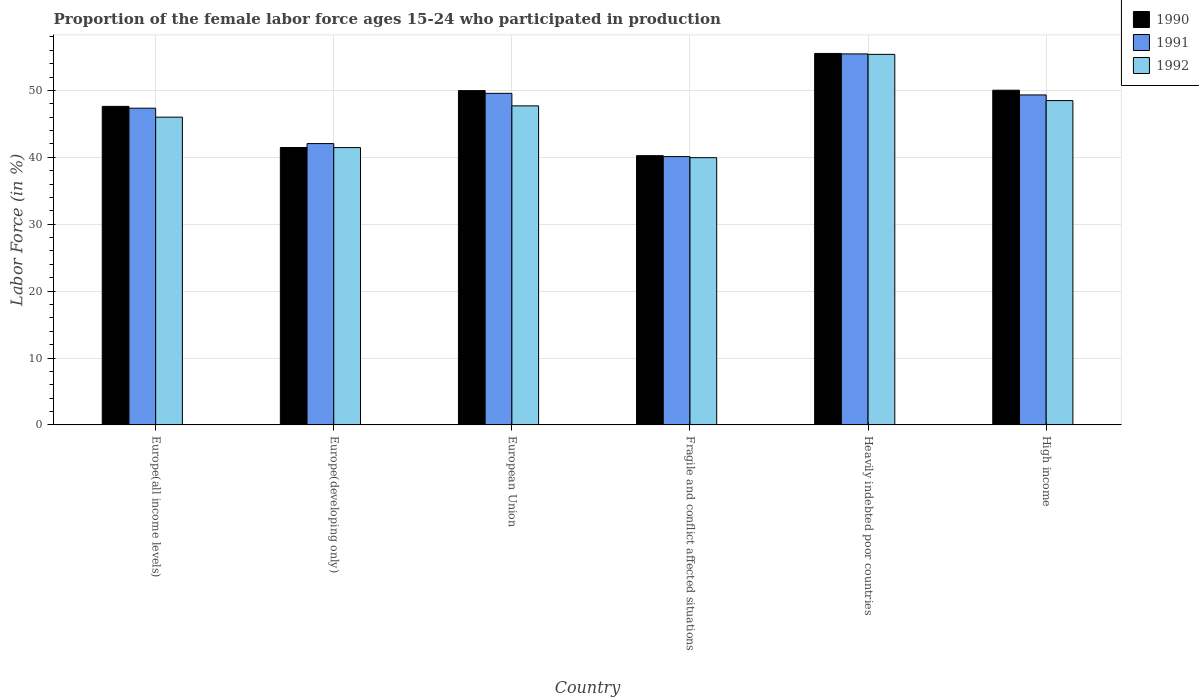How many different coloured bars are there?
Your answer should be compact. 3. How many bars are there on the 5th tick from the left?
Your answer should be compact. 3. What is the label of the 5th group of bars from the left?
Offer a terse response. Heavily indebted poor countries. What is the proportion of the female labor force who participated in production in 1991 in Fragile and conflict affected situations?
Keep it short and to the point. 40.11. Across all countries, what is the maximum proportion of the female labor force who participated in production in 1991?
Provide a short and direct response. 55.46. Across all countries, what is the minimum proportion of the female labor force who participated in production in 1990?
Offer a terse response. 40.25. In which country was the proportion of the female labor force who participated in production in 1992 maximum?
Make the answer very short. Heavily indebted poor countries. In which country was the proportion of the female labor force who participated in production in 1991 minimum?
Keep it short and to the point. Fragile and conflict affected situations. What is the total proportion of the female labor force who participated in production in 1990 in the graph?
Give a very brief answer. 284.87. What is the difference between the proportion of the female labor force who participated in production in 1992 in Europe(all income levels) and that in Heavily indebted poor countries?
Your response must be concise. -9.39. What is the difference between the proportion of the female labor force who participated in production in 1990 in Fragile and conflict affected situations and the proportion of the female labor force who participated in production in 1991 in Heavily indebted poor countries?
Offer a very short reply. -15.21. What is the average proportion of the female labor force who participated in production in 1992 per country?
Offer a very short reply. 46.5. What is the difference between the proportion of the female labor force who participated in production of/in 1990 and proportion of the female labor force who participated in production of/in 1992 in High income?
Offer a very short reply. 1.55. In how many countries, is the proportion of the female labor force who participated in production in 1992 greater than 24 %?
Make the answer very short. 6. What is the ratio of the proportion of the female labor force who participated in production in 1990 in Heavily indebted poor countries to that in High income?
Make the answer very short. 1.11. Is the proportion of the female labor force who participated in production in 1991 in Europe(all income levels) less than that in Heavily indebted poor countries?
Your response must be concise. Yes. Is the difference between the proportion of the female labor force who participated in production in 1990 in Europe(developing only) and European Union greater than the difference between the proportion of the female labor force who participated in production in 1992 in Europe(developing only) and European Union?
Ensure brevity in your answer.  No. What is the difference between the highest and the second highest proportion of the female labor force who participated in production in 1992?
Make the answer very short. 0.79. What is the difference between the highest and the lowest proportion of the female labor force who participated in production in 1992?
Your response must be concise. 15.44. Is the sum of the proportion of the female labor force who participated in production in 1992 in Fragile and conflict affected situations and Heavily indebted poor countries greater than the maximum proportion of the female labor force who participated in production in 1990 across all countries?
Ensure brevity in your answer.  Yes. Is it the case that in every country, the sum of the proportion of the female labor force who participated in production in 1990 and proportion of the female labor force who participated in production in 1992 is greater than the proportion of the female labor force who participated in production in 1991?
Offer a very short reply. Yes. How many bars are there?
Your response must be concise. 18. How many countries are there in the graph?
Make the answer very short. 6. What is the difference between two consecutive major ticks on the Y-axis?
Give a very brief answer. 10. Does the graph contain any zero values?
Ensure brevity in your answer.  No. How many legend labels are there?
Provide a short and direct response. 3. How are the legend labels stacked?
Your response must be concise. Vertical. What is the title of the graph?
Your response must be concise. Proportion of the female labor force ages 15-24 who participated in production. What is the Labor Force (in %) of 1990 in Europe(all income levels)?
Provide a short and direct response. 47.62. What is the Labor Force (in %) in 1991 in Europe(all income levels)?
Offer a terse response. 47.34. What is the Labor Force (in %) in 1992 in Europe(all income levels)?
Your response must be concise. 46. What is the Labor Force (in %) of 1990 in Europe(developing only)?
Ensure brevity in your answer.  41.47. What is the Labor Force (in %) in 1991 in Europe(developing only)?
Offer a terse response. 42.05. What is the Labor Force (in %) in 1992 in Europe(developing only)?
Your response must be concise. 41.46. What is the Labor Force (in %) in 1990 in European Union?
Offer a terse response. 49.97. What is the Labor Force (in %) of 1991 in European Union?
Offer a very short reply. 49.57. What is the Labor Force (in %) in 1992 in European Union?
Offer a terse response. 47.7. What is the Labor Force (in %) in 1990 in Fragile and conflict affected situations?
Provide a short and direct response. 40.25. What is the Labor Force (in %) of 1991 in Fragile and conflict affected situations?
Provide a short and direct response. 40.11. What is the Labor Force (in %) in 1992 in Fragile and conflict affected situations?
Keep it short and to the point. 39.95. What is the Labor Force (in %) of 1990 in Heavily indebted poor countries?
Provide a succinct answer. 55.53. What is the Labor Force (in %) in 1991 in Heavily indebted poor countries?
Offer a terse response. 55.46. What is the Labor Force (in %) in 1992 in Heavily indebted poor countries?
Keep it short and to the point. 55.39. What is the Labor Force (in %) of 1990 in High income?
Offer a very short reply. 50.03. What is the Labor Force (in %) of 1991 in High income?
Ensure brevity in your answer.  49.33. What is the Labor Force (in %) of 1992 in High income?
Provide a short and direct response. 48.48. Across all countries, what is the maximum Labor Force (in %) in 1990?
Offer a very short reply. 55.53. Across all countries, what is the maximum Labor Force (in %) of 1991?
Make the answer very short. 55.46. Across all countries, what is the maximum Labor Force (in %) in 1992?
Make the answer very short. 55.39. Across all countries, what is the minimum Labor Force (in %) in 1990?
Keep it short and to the point. 40.25. Across all countries, what is the minimum Labor Force (in %) of 1991?
Provide a short and direct response. 40.11. Across all countries, what is the minimum Labor Force (in %) in 1992?
Ensure brevity in your answer.  39.95. What is the total Labor Force (in %) in 1990 in the graph?
Keep it short and to the point. 284.87. What is the total Labor Force (in %) in 1991 in the graph?
Provide a short and direct response. 283.86. What is the total Labor Force (in %) of 1992 in the graph?
Your answer should be compact. 278.98. What is the difference between the Labor Force (in %) of 1990 in Europe(all income levels) and that in Europe(developing only)?
Provide a succinct answer. 6.15. What is the difference between the Labor Force (in %) of 1991 in Europe(all income levels) and that in Europe(developing only)?
Keep it short and to the point. 5.29. What is the difference between the Labor Force (in %) of 1992 in Europe(all income levels) and that in Europe(developing only)?
Your answer should be very brief. 4.55. What is the difference between the Labor Force (in %) in 1990 in Europe(all income levels) and that in European Union?
Offer a terse response. -2.35. What is the difference between the Labor Force (in %) of 1991 in Europe(all income levels) and that in European Union?
Offer a terse response. -2.22. What is the difference between the Labor Force (in %) in 1992 in Europe(all income levels) and that in European Union?
Offer a terse response. -1.69. What is the difference between the Labor Force (in %) of 1990 in Europe(all income levels) and that in Fragile and conflict affected situations?
Give a very brief answer. 7.37. What is the difference between the Labor Force (in %) in 1991 in Europe(all income levels) and that in Fragile and conflict affected situations?
Provide a short and direct response. 7.23. What is the difference between the Labor Force (in %) in 1992 in Europe(all income levels) and that in Fragile and conflict affected situations?
Give a very brief answer. 6.05. What is the difference between the Labor Force (in %) in 1990 in Europe(all income levels) and that in Heavily indebted poor countries?
Offer a very short reply. -7.91. What is the difference between the Labor Force (in %) of 1991 in Europe(all income levels) and that in Heavily indebted poor countries?
Offer a terse response. -8.12. What is the difference between the Labor Force (in %) of 1992 in Europe(all income levels) and that in Heavily indebted poor countries?
Offer a very short reply. -9.39. What is the difference between the Labor Force (in %) of 1990 in Europe(all income levels) and that in High income?
Offer a terse response. -2.42. What is the difference between the Labor Force (in %) in 1991 in Europe(all income levels) and that in High income?
Offer a very short reply. -1.98. What is the difference between the Labor Force (in %) in 1992 in Europe(all income levels) and that in High income?
Make the answer very short. -2.48. What is the difference between the Labor Force (in %) of 1990 in Europe(developing only) and that in European Union?
Make the answer very short. -8.5. What is the difference between the Labor Force (in %) of 1991 in Europe(developing only) and that in European Union?
Offer a terse response. -7.51. What is the difference between the Labor Force (in %) of 1992 in Europe(developing only) and that in European Union?
Give a very brief answer. -6.24. What is the difference between the Labor Force (in %) in 1990 in Europe(developing only) and that in Fragile and conflict affected situations?
Ensure brevity in your answer.  1.22. What is the difference between the Labor Force (in %) in 1991 in Europe(developing only) and that in Fragile and conflict affected situations?
Offer a very short reply. 1.94. What is the difference between the Labor Force (in %) of 1992 in Europe(developing only) and that in Fragile and conflict affected situations?
Your answer should be compact. 1.51. What is the difference between the Labor Force (in %) in 1990 in Europe(developing only) and that in Heavily indebted poor countries?
Provide a short and direct response. -14.06. What is the difference between the Labor Force (in %) of 1991 in Europe(developing only) and that in Heavily indebted poor countries?
Your response must be concise. -13.41. What is the difference between the Labor Force (in %) of 1992 in Europe(developing only) and that in Heavily indebted poor countries?
Ensure brevity in your answer.  -13.93. What is the difference between the Labor Force (in %) in 1990 in Europe(developing only) and that in High income?
Provide a succinct answer. -8.57. What is the difference between the Labor Force (in %) in 1991 in Europe(developing only) and that in High income?
Offer a terse response. -7.27. What is the difference between the Labor Force (in %) in 1992 in Europe(developing only) and that in High income?
Provide a succinct answer. -7.02. What is the difference between the Labor Force (in %) in 1990 in European Union and that in Fragile and conflict affected situations?
Keep it short and to the point. 9.72. What is the difference between the Labor Force (in %) of 1991 in European Union and that in Fragile and conflict affected situations?
Give a very brief answer. 9.46. What is the difference between the Labor Force (in %) in 1992 in European Union and that in Fragile and conflict affected situations?
Your response must be concise. 7.75. What is the difference between the Labor Force (in %) of 1990 in European Union and that in Heavily indebted poor countries?
Ensure brevity in your answer.  -5.56. What is the difference between the Labor Force (in %) in 1991 in European Union and that in Heavily indebted poor countries?
Ensure brevity in your answer.  -5.89. What is the difference between the Labor Force (in %) of 1992 in European Union and that in Heavily indebted poor countries?
Keep it short and to the point. -7.7. What is the difference between the Labor Force (in %) in 1990 in European Union and that in High income?
Keep it short and to the point. -0.06. What is the difference between the Labor Force (in %) of 1991 in European Union and that in High income?
Your response must be concise. 0.24. What is the difference between the Labor Force (in %) of 1992 in European Union and that in High income?
Your answer should be very brief. -0.79. What is the difference between the Labor Force (in %) of 1990 in Fragile and conflict affected situations and that in Heavily indebted poor countries?
Your answer should be very brief. -15.28. What is the difference between the Labor Force (in %) in 1991 in Fragile and conflict affected situations and that in Heavily indebted poor countries?
Your response must be concise. -15.35. What is the difference between the Labor Force (in %) in 1992 in Fragile and conflict affected situations and that in Heavily indebted poor countries?
Your answer should be very brief. -15.44. What is the difference between the Labor Force (in %) of 1990 in Fragile and conflict affected situations and that in High income?
Your answer should be compact. -9.78. What is the difference between the Labor Force (in %) of 1991 in Fragile and conflict affected situations and that in High income?
Your answer should be compact. -9.22. What is the difference between the Labor Force (in %) in 1992 in Fragile and conflict affected situations and that in High income?
Offer a very short reply. -8.53. What is the difference between the Labor Force (in %) of 1990 in Heavily indebted poor countries and that in High income?
Ensure brevity in your answer.  5.5. What is the difference between the Labor Force (in %) in 1991 in Heavily indebted poor countries and that in High income?
Keep it short and to the point. 6.13. What is the difference between the Labor Force (in %) in 1992 in Heavily indebted poor countries and that in High income?
Offer a terse response. 6.91. What is the difference between the Labor Force (in %) in 1990 in Europe(all income levels) and the Labor Force (in %) in 1991 in Europe(developing only)?
Ensure brevity in your answer.  5.56. What is the difference between the Labor Force (in %) in 1990 in Europe(all income levels) and the Labor Force (in %) in 1992 in Europe(developing only)?
Ensure brevity in your answer.  6.16. What is the difference between the Labor Force (in %) in 1991 in Europe(all income levels) and the Labor Force (in %) in 1992 in Europe(developing only)?
Give a very brief answer. 5.89. What is the difference between the Labor Force (in %) in 1990 in Europe(all income levels) and the Labor Force (in %) in 1991 in European Union?
Offer a very short reply. -1.95. What is the difference between the Labor Force (in %) of 1990 in Europe(all income levels) and the Labor Force (in %) of 1992 in European Union?
Keep it short and to the point. -0.08. What is the difference between the Labor Force (in %) of 1991 in Europe(all income levels) and the Labor Force (in %) of 1992 in European Union?
Provide a short and direct response. -0.35. What is the difference between the Labor Force (in %) in 1990 in Europe(all income levels) and the Labor Force (in %) in 1991 in Fragile and conflict affected situations?
Your answer should be very brief. 7.51. What is the difference between the Labor Force (in %) in 1990 in Europe(all income levels) and the Labor Force (in %) in 1992 in Fragile and conflict affected situations?
Provide a succinct answer. 7.67. What is the difference between the Labor Force (in %) of 1991 in Europe(all income levels) and the Labor Force (in %) of 1992 in Fragile and conflict affected situations?
Provide a short and direct response. 7.4. What is the difference between the Labor Force (in %) in 1990 in Europe(all income levels) and the Labor Force (in %) in 1991 in Heavily indebted poor countries?
Your response must be concise. -7.84. What is the difference between the Labor Force (in %) in 1990 in Europe(all income levels) and the Labor Force (in %) in 1992 in Heavily indebted poor countries?
Ensure brevity in your answer.  -7.77. What is the difference between the Labor Force (in %) of 1991 in Europe(all income levels) and the Labor Force (in %) of 1992 in Heavily indebted poor countries?
Give a very brief answer. -8.05. What is the difference between the Labor Force (in %) in 1990 in Europe(all income levels) and the Labor Force (in %) in 1991 in High income?
Give a very brief answer. -1.71. What is the difference between the Labor Force (in %) in 1990 in Europe(all income levels) and the Labor Force (in %) in 1992 in High income?
Your response must be concise. -0.86. What is the difference between the Labor Force (in %) of 1991 in Europe(all income levels) and the Labor Force (in %) of 1992 in High income?
Offer a very short reply. -1.14. What is the difference between the Labor Force (in %) in 1990 in Europe(developing only) and the Labor Force (in %) in 1991 in European Union?
Your answer should be compact. -8.1. What is the difference between the Labor Force (in %) of 1990 in Europe(developing only) and the Labor Force (in %) of 1992 in European Union?
Keep it short and to the point. -6.23. What is the difference between the Labor Force (in %) in 1991 in Europe(developing only) and the Labor Force (in %) in 1992 in European Union?
Make the answer very short. -5.64. What is the difference between the Labor Force (in %) of 1990 in Europe(developing only) and the Labor Force (in %) of 1991 in Fragile and conflict affected situations?
Your answer should be very brief. 1.36. What is the difference between the Labor Force (in %) in 1990 in Europe(developing only) and the Labor Force (in %) in 1992 in Fragile and conflict affected situations?
Provide a short and direct response. 1.52. What is the difference between the Labor Force (in %) of 1991 in Europe(developing only) and the Labor Force (in %) of 1992 in Fragile and conflict affected situations?
Ensure brevity in your answer.  2.11. What is the difference between the Labor Force (in %) in 1990 in Europe(developing only) and the Labor Force (in %) in 1991 in Heavily indebted poor countries?
Provide a short and direct response. -13.99. What is the difference between the Labor Force (in %) in 1990 in Europe(developing only) and the Labor Force (in %) in 1992 in Heavily indebted poor countries?
Provide a succinct answer. -13.92. What is the difference between the Labor Force (in %) of 1991 in Europe(developing only) and the Labor Force (in %) of 1992 in Heavily indebted poor countries?
Your response must be concise. -13.34. What is the difference between the Labor Force (in %) of 1990 in Europe(developing only) and the Labor Force (in %) of 1991 in High income?
Offer a terse response. -7.86. What is the difference between the Labor Force (in %) in 1990 in Europe(developing only) and the Labor Force (in %) in 1992 in High income?
Make the answer very short. -7.01. What is the difference between the Labor Force (in %) of 1991 in Europe(developing only) and the Labor Force (in %) of 1992 in High income?
Your answer should be compact. -6.43. What is the difference between the Labor Force (in %) of 1990 in European Union and the Labor Force (in %) of 1991 in Fragile and conflict affected situations?
Provide a short and direct response. 9.86. What is the difference between the Labor Force (in %) of 1990 in European Union and the Labor Force (in %) of 1992 in Fragile and conflict affected situations?
Offer a terse response. 10.02. What is the difference between the Labor Force (in %) in 1991 in European Union and the Labor Force (in %) in 1992 in Fragile and conflict affected situations?
Keep it short and to the point. 9.62. What is the difference between the Labor Force (in %) of 1990 in European Union and the Labor Force (in %) of 1991 in Heavily indebted poor countries?
Your response must be concise. -5.49. What is the difference between the Labor Force (in %) in 1990 in European Union and the Labor Force (in %) in 1992 in Heavily indebted poor countries?
Your answer should be compact. -5.42. What is the difference between the Labor Force (in %) of 1991 in European Union and the Labor Force (in %) of 1992 in Heavily indebted poor countries?
Offer a very short reply. -5.83. What is the difference between the Labor Force (in %) of 1990 in European Union and the Labor Force (in %) of 1991 in High income?
Ensure brevity in your answer.  0.64. What is the difference between the Labor Force (in %) in 1990 in European Union and the Labor Force (in %) in 1992 in High income?
Offer a very short reply. 1.49. What is the difference between the Labor Force (in %) of 1991 in European Union and the Labor Force (in %) of 1992 in High income?
Your answer should be compact. 1.08. What is the difference between the Labor Force (in %) in 1990 in Fragile and conflict affected situations and the Labor Force (in %) in 1991 in Heavily indebted poor countries?
Your response must be concise. -15.21. What is the difference between the Labor Force (in %) in 1990 in Fragile and conflict affected situations and the Labor Force (in %) in 1992 in Heavily indebted poor countries?
Your answer should be very brief. -15.14. What is the difference between the Labor Force (in %) in 1991 in Fragile and conflict affected situations and the Labor Force (in %) in 1992 in Heavily indebted poor countries?
Make the answer very short. -15.28. What is the difference between the Labor Force (in %) in 1990 in Fragile and conflict affected situations and the Labor Force (in %) in 1991 in High income?
Keep it short and to the point. -9.08. What is the difference between the Labor Force (in %) in 1990 in Fragile and conflict affected situations and the Labor Force (in %) in 1992 in High income?
Provide a short and direct response. -8.23. What is the difference between the Labor Force (in %) of 1991 in Fragile and conflict affected situations and the Labor Force (in %) of 1992 in High income?
Your answer should be compact. -8.37. What is the difference between the Labor Force (in %) in 1990 in Heavily indebted poor countries and the Labor Force (in %) in 1991 in High income?
Your answer should be compact. 6.2. What is the difference between the Labor Force (in %) of 1990 in Heavily indebted poor countries and the Labor Force (in %) of 1992 in High income?
Ensure brevity in your answer.  7.05. What is the difference between the Labor Force (in %) in 1991 in Heavily indebted poor countries and the Labor Force (in %) in 1992 in High income?
Make the answer very short. 6.98. What is the average Labor Force (in %) in 1990 per country?
Provide a short and direct response. 47.48. What is the average Labor Force (in %) of 1991 per country?
Offer a very short reply. 47.31. What is the average Labor Force (in %) of 1992 per country?
Your answer should be very brief. 46.5. What is the difference between the Labor Force (in %) in 1990 and Labor Force (in %) in 1991 in Europe(all income levels)?
Your response must be concise. 0.27. What is the difference between the Labor Force (in %) of 1990 and Labor Force (in %) of 1992 in Europe(all income levels)?
Provide a succinct answer. 1.61. What is the difference between the Labor Force (in %) of 1991 and Labor Force (in %) of 1992 in Europe(all income levels)?
Offer a terse response. 1.34. What is the difference between the Labor Force (in %) of 1990 and Labor Force (in %) of 1991 in Europe(developing only)?
Offer a very short reply. -0.59. What is the difference between the Labor Force (in %) in 1990 and Labor Force (in %) in 1992 in Europe(developing only)?
Your answer should be very brief. 0.01. What is the difference between the Labor Force (in %) in 1991 and Labor Force (in %) in 1992 in Europe(developing only)?
Offer a very short reply. 0.6. What is the difference between the Labor Force (in %) of 1990 and Labor Force (in %) of 1991 in European Union?
Keep it short and to the point. 0.4. What is the difference between the Labor Force (in %) in 1990 and Labor Force (in %) in 1992 in European Union?
Ensure brevity in your answer.  2.27. What is the difference between the Labor Force (in %) in 1991 and Labor Force (in %) in 1992 in European Union?
Offer a very short reply. 1.87. What is the difference between the Labor Force (in %) of 1990 and Labor Force (in %) of 1991 in Fragile and conflict affected situations?
Give a very brief answer. 0.14. What is the difference between the Labor Force (in %) in 1990 and Labor Force (in %) in 1992 in Fragile and conflict affected situations?
Provide a succinct answer. 0.3. What is the difference between the Labor Force (in %) of 1991 and Labor Force (in %) of 1992 in Fragile and conflict affected situations?
Your answer should be compact. 0.16. What is the difference between the Labor Force (in %) in 1990 and Labor Force (in %) in 1991 in Heavily indebted poor countries?
Your answer should be compact. 0.07. What is the difference between the Labor Force (in %) of 1990 and Labor Force (in %) of 1992 in Heavily indebted poor countries?
Ensure brevity in your answer.  0.14. What is the difference between the Labor Force (in %) of 1991 and Labor Force (in %) of 1992 in Heavily indebted poor countries?
Your answer should be very brief. 0.07. What is the difference between the Labor Force (in %) in 1990 and Labor Force (in %) in 1991 in High income?
Offer a terse response. 0.71. What is the difference between the Labor Force (in %) in 1990 and Labor Force (in %) in 1992 in High income?
Your response must be concise. 1.55. What is the difference between the Labor Force (in %) in 1991 and Labor Force (in %) in 1992 in High income?
Provide a succinct answer. 0.85. What is the ratio of the Labor Force (in %) of 1990 in Europe(all income levels) to that in Europe(developing only)?
Provide a succinct answer. 1.15. What is the ratio of the Labor Force (in %) in 1991 in Europe(all income levels) to that in Europe(developing only)?
Offer a very short reply. 1.13. What is the ratio of the Labor Force (in %) in 1992 in Europe(all income levels) to that in Europe(developing only)?
Make the answer very short. 1.11. What is the ratio of the Labor Force (in %) of 1990 in Europe(all income levels) to that in European Union?
Offer a terse response. 0.95. What is the ratio of the Labor Force (in %) in 1991 in Europe(all income levels) to that in European Union?
Provide a succinct answer. 0.96. What is the ratio of the Labor Force (in %) of 1992 in Europe(all income levels) to that in European Union?
Offer a very short reply. 0.96. What is the ratio of the Labor Force (in %) in 1990 in Europe(all income levels) to that in Fragile and conflict affected situations?
Offer a very short reply. 1.18. What is the ratio of the Labor Force (in %) in 1991 in Europe(all income levels) to that in Fragile and conflict affected situations?
Keep it short and to the point. 1.18. What is the ratio of the Labor Force (in %) of 1992 in Europe(all income levels) to that in Fragile and conflict affected situations?
Make the answer very short. 1.15. What is the ratio of the Labor Force (in %) of 1990 in Europe(all income levels) to that in Heavily indebted poor countries?
Provide a short and direct response. 0.86. What is the ratio of the Labor Force (in %) of 1991 in Europe(all income levels) to that in Heavily indebted poor countries?
Provide a succinct answer. 0.85. What is the ratio of the Labor Force (in %) of 1992 in Europe(all income levels) to that in Heavily indebted poor countries?
Provide a short and direct response. 0.83. What is the ratio of the Labor Force (in %) in 1990 in Europe(all income levels) to that in High income?
Offer a very short reply. 0.95. What is the ratio of the Labor Force (in %) of 1991 in Europe(all income levels) to that in High income?
Your answer should be compact. 0.96. What is the ratio of the Labor Force (in %) in 1992 in Europe(all income levels) to that in High income?
Your answer should be very brief. 0.95. What is the ratio of the Labor Force (in %) of 1990 in Europe(developing only) to that in European Union?
Your answer should be compact. 0.83. What is the ratio of the Labor Force (in %) of 1991 in Europe(developing only) to that in European Union?
Your answer should be compact. 0.85. What is the ratio of the Labor Force (in %) in 1992 in Europe(developing only) to that in European Union?
Give a very brief answer. 0.87. What is the ratio of the Labor Force (in %) in 1990 in Europe(developing only) to that in Fragile and conflict affected situations?
Your answer should be very brief. 1.03. What is the ratio of the Labor Force (in %) in 1991 in Europe(developing only) to that in Fragile and conflict affected situations?
Provide a succinct answer. 1.05. What is the ratio of the Labor Force (in %) of 1992 in Europe(developing only) to that in Fragile and conflict affected situations?
Your response must be concise. 1.04. What is the ratio of the Labor Force (in %) of 1990 in Europe(developing only) to that in Heavily indebted poor countries?
Offer a terse response. 0.75. What is the ratio of the Labor Force (in %) of 1991 in Europe(developing only) to that in Heavily indebted poor countries?
Provide a succinct answer. 0.76. What is the ratio of the Labor Force (in %) of 1992 in Europe(developing only) to that in Heavily indebted poor countries?
Your answer should be very brief. 0.75. What is the ratio of the Labor Force (in %) in 1990 in Europe(developing only) to that in High income?
Offer a terse response. 0.83. What is the ratio of the Labor Force (in %) of 1991 in Europe(developing only) to that in High income?
Keep it short and to the point. 0.85. What is the ratio of the Labor Force (in %) of 1992 in Europe(developing only) to that in High income?
Make the answer very short. 0.86. What is the ratio of the Labor Force (in %) of 1990 in European Union to that in Fragile and conflict affected situations?
Offer a very short reply. 1.24. What is the ratio of the Labor Force (in %) of 1991 in European Union to that in Fragile and conflict affected situations?
Offer a terse response. 1.24. What is the ratio of the Labor Force (in %) in 1992 in European Union to that in Fragile and conflict affected situations?
Ensure brevity in your answer.  1.19. What is the ratio of the Labor Force (in %) of 1990 in European Union to that in Heavily indebted poor countries?
Your response must be concise. 0.9. What is the ratio of the Labor Force (in %) of 1991 in European Union to that in Heavily indebted poor countries?
Offer a very short reply. 0.89. What is the ratio of the Labor Force (in %) in 1992 in European Union to that in Heavily indebted poor countries?
Offer a very short reply. 0.86. What is the ratio of the Labor Force (in %) in 1990 in European Union to that in High income?
Keep it short and to the point. 1. What is the ratio of the Labor Force (in %) of 1992 in European Union to that in High income?
Provide a succinct answer. 0.98. What is the ratio of the Labor Force (in %) in 1990 in Fragile and conflict affected situations to that in Heavily indebted poor countries?
Keep it short and to the point. 0.72. What is the ratio of the Labor Force (in %) in 1991 in Fragile and conflict affected situations to that in Heavily indebted poor countries?
Keep it short and to the point. 0.72. What is the ratio of the Labor Force (in %) in 1992 in Fragile and conflict affected situations to that in Heavily indebted poor countries?
Make the answer very short. 0.72. What is the ratio of the Labor Force (in %) of 1990 in Fragile and conflict affected situations to that in High income?
Ensure brevity in your answer.  0.8. What is the ratio of the Labor Force (in %) of 1991 in Fragile and conflict affected situations to that in High income?
Provide a succinct answer. 0.81. What is the ratio of the Labor Force (in %) of 1992 in Fragile and conflict affected situations to that in High income?
Offer a terse response. 0.82. What is the ratio of the Labor Force (in %) of 1990 in Heavily indebted poor countries to that in High income?
Provide a short and direct response. 1.11. What is the ratio of the Labor Force (in %) of 1991 in Heavily indebted poor countries to that in High income?
Ensure brevity in your answer.  1.12. What is the ratio of the Labor Force (in %) of 1992 in Heavily indebted poor countries to that in High income?
Provide a succinct answer. 1.14. What is the difference between the highest and the second highest Labor Force (in %) in 1990?
Offer a very short reply. 5.5. What is the difference between the highest and the second highest Labor Force (in %) of 1991?
Provide a short and direct response. 5.89. What is the difference between the highest and the second highest Labor Force (in %) of 1992?
Provide a short and direct response. 6.91. What is the difference between the highest and the lowest Labor Force (in %) of 1990?
Offer a very short reply. 15.28. What is the difference between the highest and the lowest Labor Force (in %) in 1991?
Ensure brevity in your answer.  15.35. What is the difference between the highest and the lowest Labor Force (in %) in 1992?
Keep it short and to the point. 15.44. 